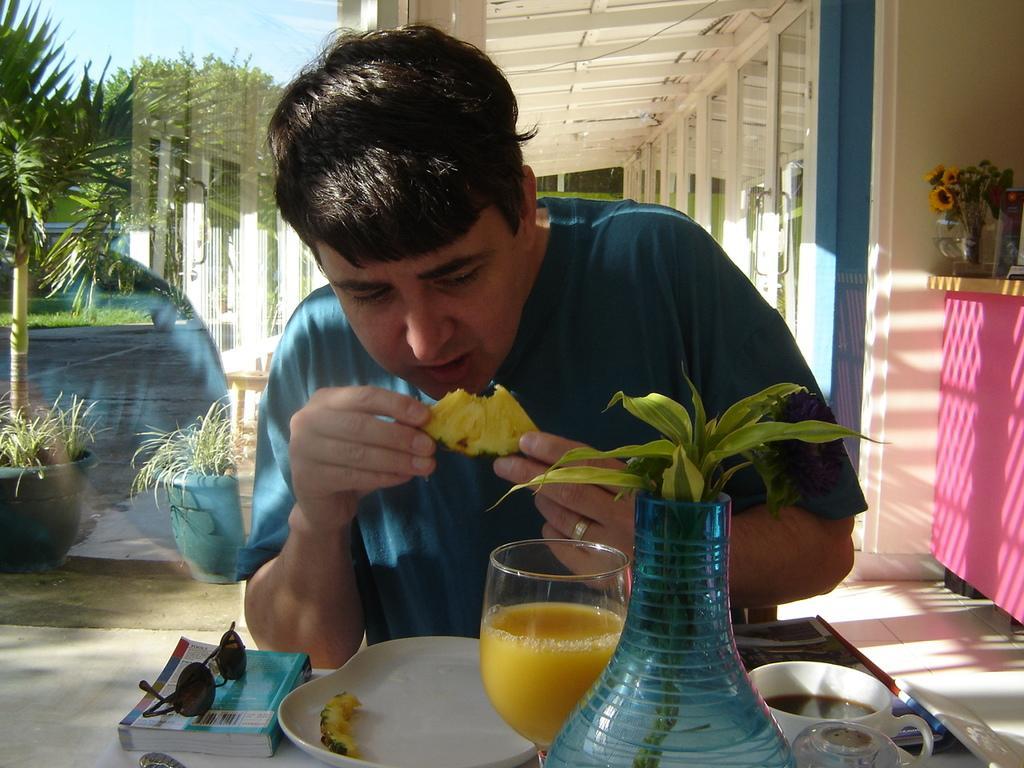Can you describe this image briefly? In this picture, we see a man in the blue T-shirt is sitting on the chair. He is holding an edible in his hand. In front of him, we see a table on which a book, goggles, plate containing an edible, glass containing the cool drink, flower vase, cup of coffee and a glass are placed. On the right side, we see a pink table on which the flower vase is placed. Beside that, we see a wall and the doors. On the left side, we see the plant pots. There are trees in the background. At the top, we see the roof of the building and the sky. 